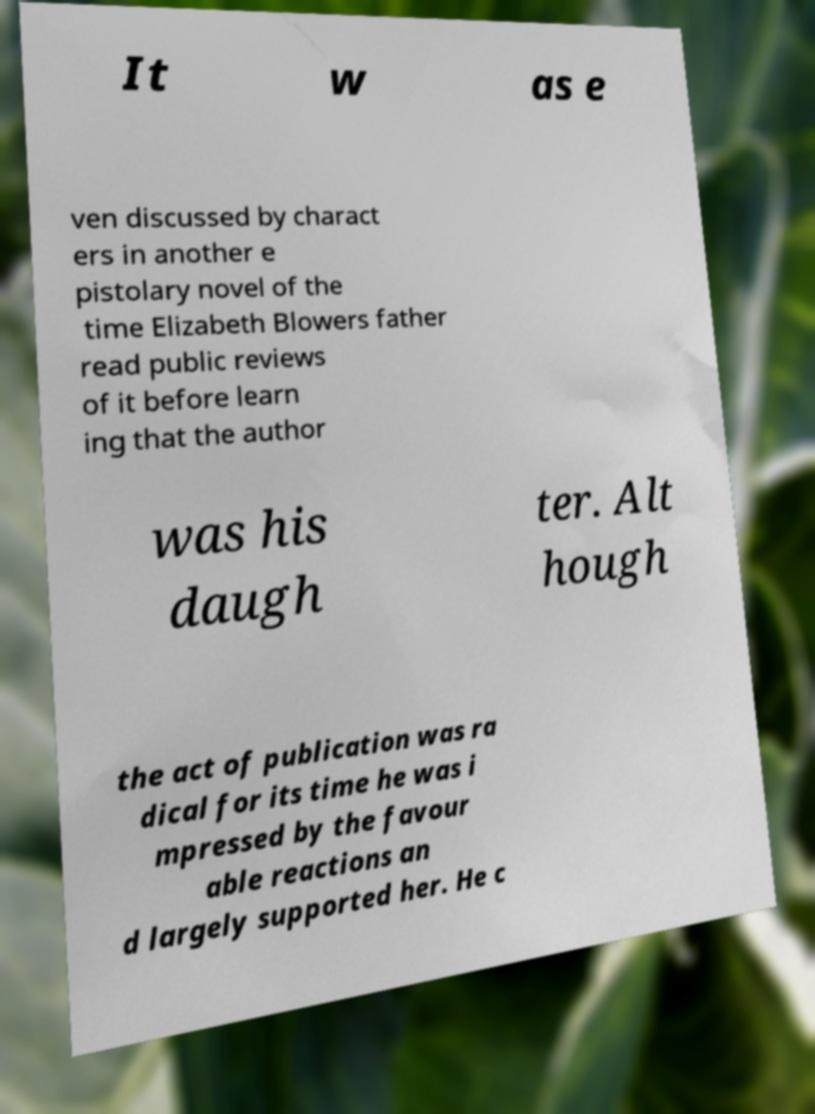Can you read and provide the text displayed in the image?This photo seems to have some interesting text. Can you extract and type it out for me? It w as e ven discussed by charact ers in another e pistolary novel of the time Elizabeth Blowers father read public reviews of it before learn ing that the author was his daugh ter. Alt hough the act of publication was ra dical for its time he was i mpressed by the favour able reactions an d largely supported her. He c 